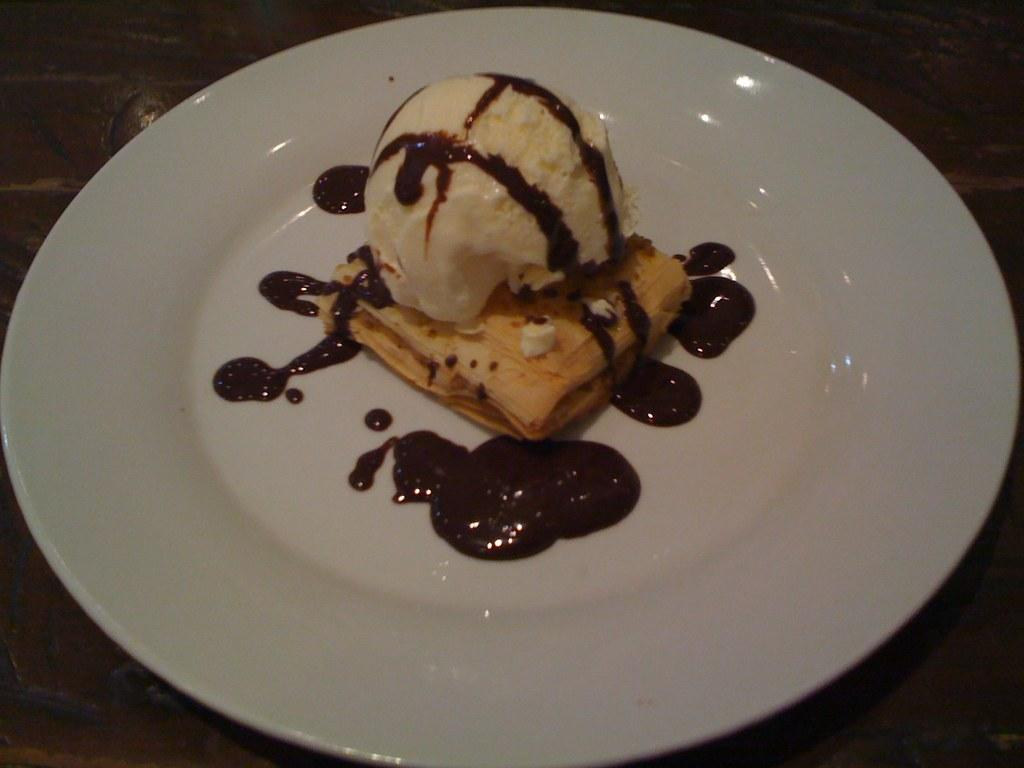What is on the plate that is visible in the image? There is food in a plate in the image. What can be seen in the background of the image? The background of the image is dark. What type of plants can be seen growing in the image? There are no plants visible in the image; it only shows food on a plate and a dark background. Is there any poison present in the food on the plate? There is no indication of poison in the image, as it only shows food on a plate and a dark background. 